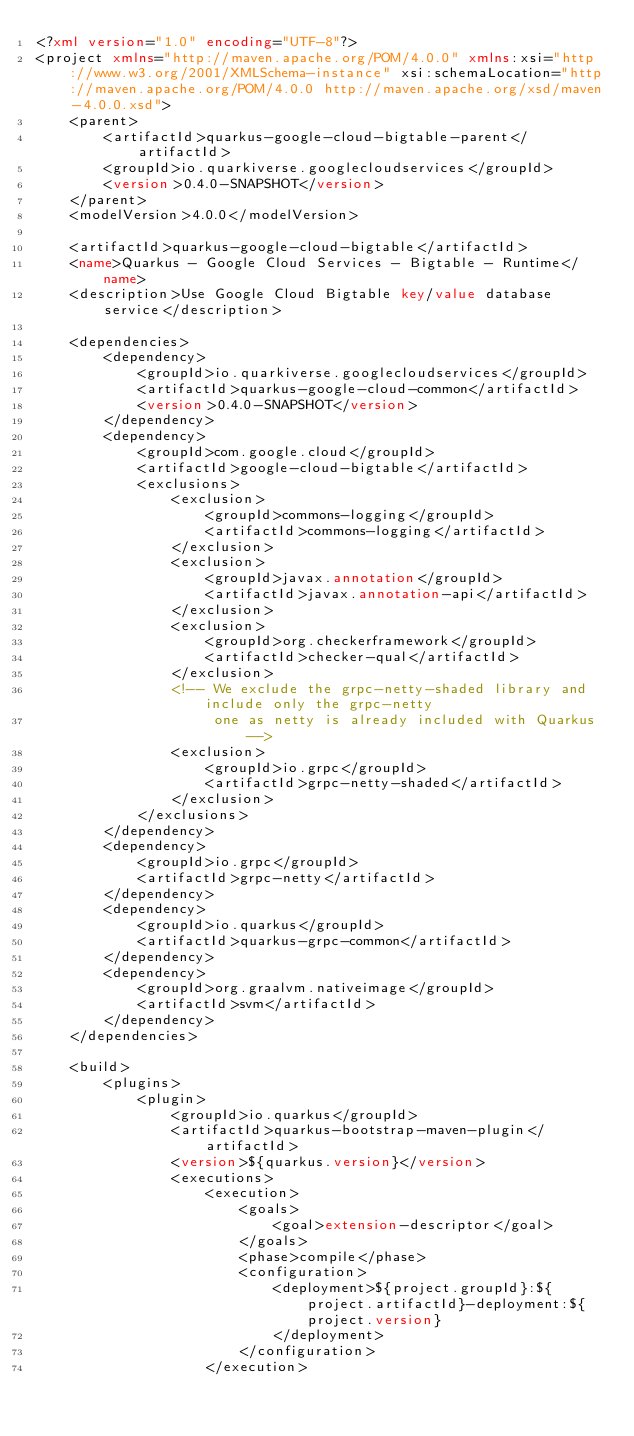Convert code to text. <code><loc_0><loc_0><loc_500><loc_500><_XML_><?xml version="1.0" encoding="UTF-8"?>
<project xmlns="http://maven.apache.org/POM/4.0.0" xmlns:xsi="http://www.w3.org/2001/XMLSchema-instance" xsi:schemaLocation="http://maven.apache.org/POM/4.0.0 http://maven.apache.org/xsd/maven-4.0.0.xsd">
    <parent>
        <artifactId>quarkus-google-cloud-bigtable-parent</artifactId>
        <groupId>io.quarkiverse.googlecloudservices</groupId>
        <version>0.4.0-SNAPSHOT</version>
    </parent>
    <modelVersion>4.0.0</modelVersion>

    <artifactId>quarkus-google-cloud-bigtable</artifactId>
    <name>Quarkus - Google Cloud Services - Bigtable - Runtime</name>
    <description>Use Google Cloud Bigtable key/value database service</description>

    <dependencies>
        <dependency>
            <groupId>io.quarkiverse.googlecloudservices</groupId>
            <artifactId>quarkus-google-cloud-common</artifactId>
            <version>0.4.0-SNAPSHOT</version>
        </dependency>
        <dependency>
            <groupId>com.google.cloud</groupId>
            <artifactId>google-cloud-bigtable</artifactId>
            <exclusions>
                <exclusion>
                    <groupId>commons-logging</groupId>
                    <artifactId>commons-logging</artifactId>
                </exclusion>
                <exclusion>
                    <groupId>javax.annotation</groupId>
                    <artifactId>javax.annotation-api</artifactId>
                </exclusion>
                <exclusion>
                    <groupId>org.checkerframework</groupId>
                    <artifactId>checker-qual</artifactId>
                </exclusion>
                <!-- We exclude the grpc-netty-shaded library and include only the grpc-netty
                     one as netty is already included with Quarkus -->
                <exclusion>
                    <groupId>io.grpc</groupId>
                    <artifactId>grpc-netty-shaded</artifactId>
                </exclusion>
            </exclusions>
        </dependency>
        <dependency>
            <groupId>io.grpc</groupId>
            <artifactId>grpc-netty</artifactId>
        </dependency>
        <dependency>
            <groupId>io.quarkus</groupId>
            <artifactId>quarkus-grpc-common</artifactId>
        </dependency>
        <dependency>
            <groupId>org.graalvm.nativeimage</groupId>
            <artifactId>svm</artifactId>
        </dependency>
    </dependencies>

    <build>
        <plugins>
            <plugin>
                <groupId>io.quarkus</groupId>
                <artifactId>quarkus-bootstrap-maven-plugin</artifactId>
                <version>${quarkus.version}</version>
                <executions>
                    <execution>
                        <goals>
                            <goal>extension-descriptor</goal>
                        </goals>
                        <phase>compile</phase>
                        <configuration>
                            <deployment>${project.groupId}:${project.artifactId}-deployment:${project.version}
                            </deployment>
                        </configuration>
                    </execution></code> 